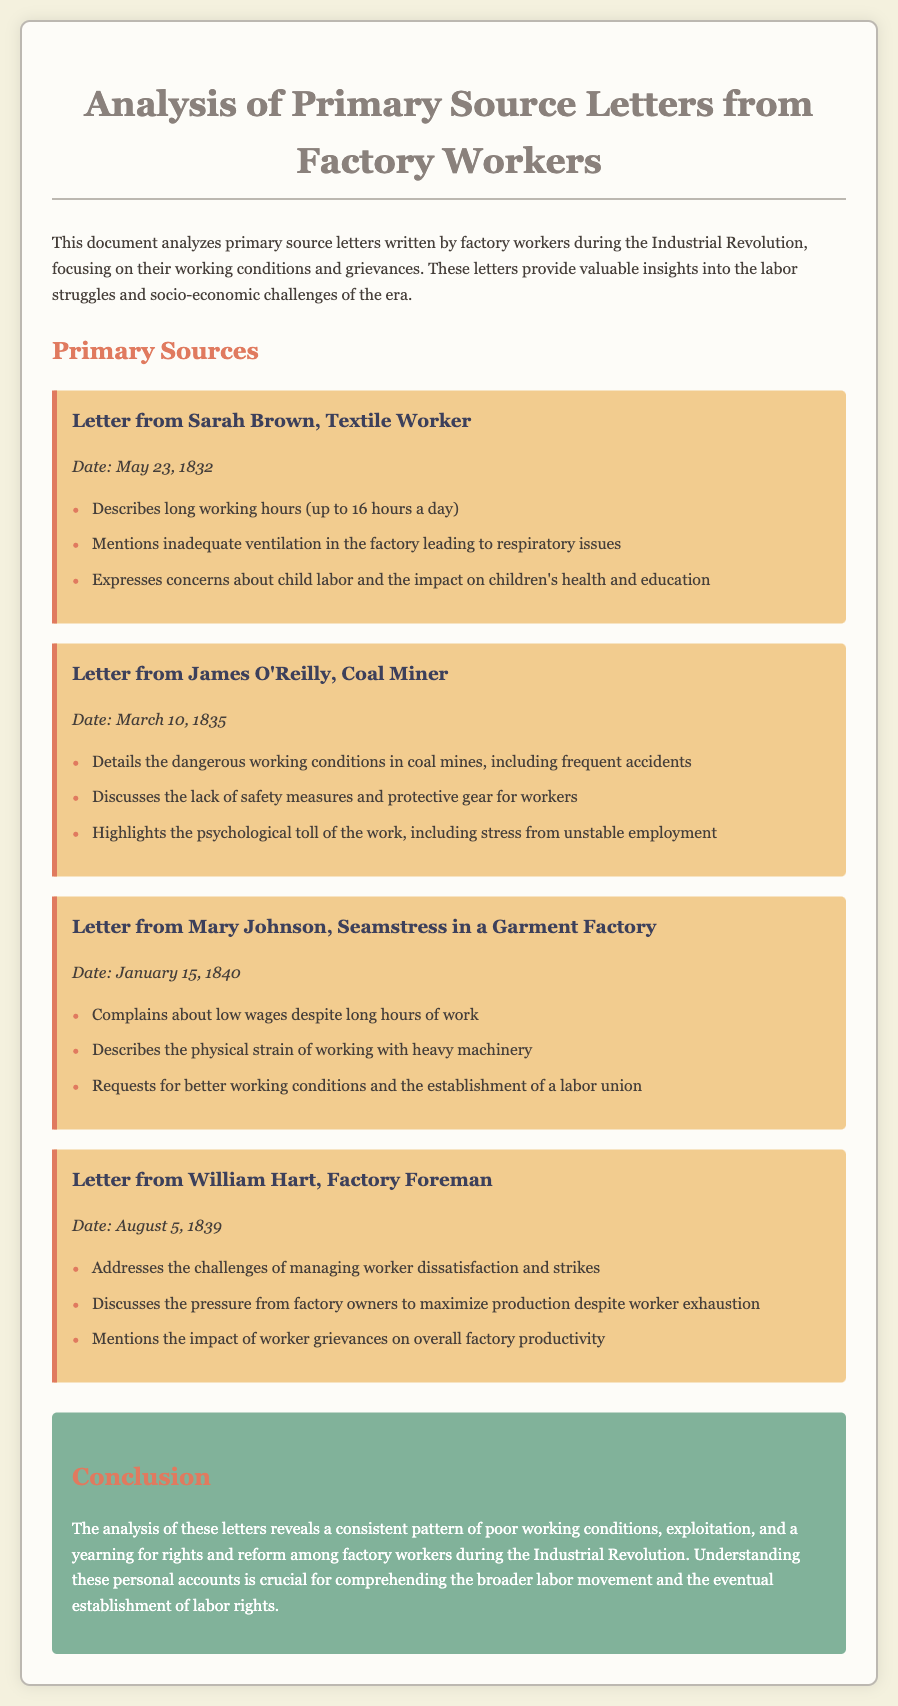What is the date of Sarah Brown's letter? The date of Sarah Brown's letter is clearly mentioned in the document as May 23, 1832.
Answer: May 23, 1832 What are the long working hours mentioned in the letters? The letters detail that workers faced long working hours, specifically stating up to 16 hours a day as noted by Sarah Brown.
Answer: 16 hours a day What industry does Mary Johnson work in? The document identifies Mary Johnson as a seamstress in a garment factory, specifying her occupation and industry.
Answer: Garment Factory What health issue is linked to inadequate ventilation in factories? Sarah Brown's letter mentions respiratory issues arising from the poor air quality due to inadequate ventilation in the factory.
Answer: Respiratory issues What is a key concern expressed by James O'Reilly in his letter? James O'Reilly highlights the dangerous working conditions in coal mines, which is one of the main concerns he expresses.
Answer: Dangerous working conditions What does William Hart discuss in relation to worker grievances? William Hart addresses how worker grievances impact overall factory productivity, indicating a relationship between dissatisfaction and productivity levels.
Answer: Overall factory productivity Who requests the establishment of a labor union? Mary Johnson explicitly mentions the need for better working conditions and requests the establishment of a labor union in her letter.
Answer: Mary Johnson What is the overarching theme in the conclusion of the document? The conclusion emphasizes the consistent patterns of poor working conditions and workers' yearning for rights and reform throughout the letters analyzed.
Answer: Poor working conditions When was the letter from James O'Reilly written? The date of James O'Reilly's letter is provided as March 10, 1835, which can be found in the document itself.
Answer: March 10, 1835 